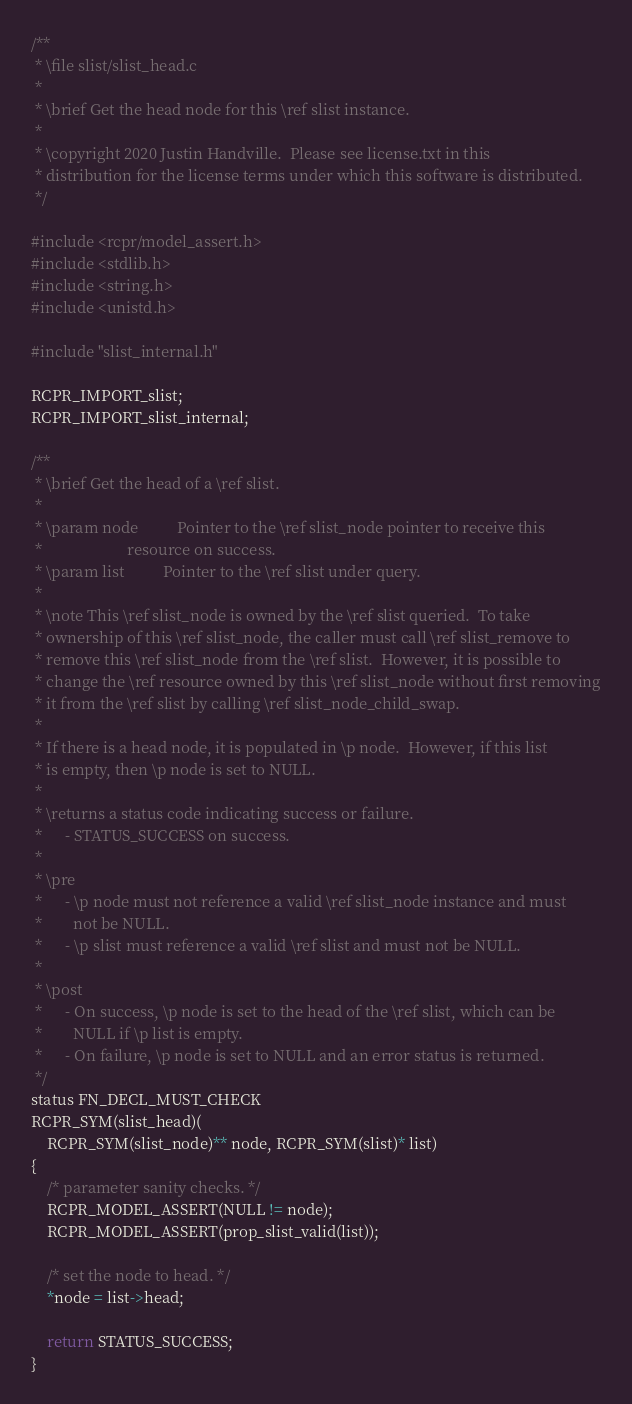<code> <loc_0><loc_0><loc_500><loc_500><_C_>/**
 * \file slist/slist_head.c
 *
 * \brief Get the head node for this \ref slist instance.
 *
 * \copyright 2020 Justin Handville.  Please see license.txt in this
 * distribution for the license terms under which this software is distributed.
 */

#include <rcpr/model_assert.h>
#include <stdlib.h>
#include <string.h>
#include <unistd.h>

#include "slist_internal.h"

RCPR_IMPORT_slist;
RCPR_IMPORT_slist_internal;

/**
 * \brief Get the head of a \ref slist.
 *
 * \param node          Pointer to the \ref slist_node pointer to receive this
 *                      resource on success.
 * \param list          Pointer to the \ref slist under query.
 *
 * \note This \ref slist_node is owned by the \ref slist queried.  To take
 * ownership of this \ref slist_node, the caller must call \ref slist_remove to
 * remove this \ref slist_node from the \ref slist.  However, it is possible to
 * change the \ref resource owned by this \ref slist_node without first removing
 * it from the \ref slist by calling \ref slist_node_child_swap.
 *
 * If there is a head node, it is populated in \p node.  However, if this list
 * is empty, then \p node is set to NULL.
 *
 * \returns a status code indicating success or failure.
 *      - STATUS_SUCCESS on success.
 *
 * \pre
 *      - \p node must not reference a valid \ref slist_node instance and must
 *        not be NULL.
 *      - \p slist must reference a valid \ref slist and must not be NULL.
 *
 * \post
 *      - On success, \p node is set to the head of the \ref slist, which can be
 *        NULL if \p list is empty.
 *      - On failure, \p node is set to NULL and an error status is returned.
 */
status FN_DECL_MUST_CHECK
RCPR_SYM(slist_head)(
    RCPR_SYM(slist_node)** node, RCPR_SYM(slist)* list)
{
    /* parameter sanity checks. */
    RCPR_MODEL_ASSERT(NULL != node);
    RCPR_MODEL_ASSERT(prop_slist_valid(list));

    /* set the node to head. */
    *node = list->head;

    return STATUS_SUCCESS;
}
</code> 